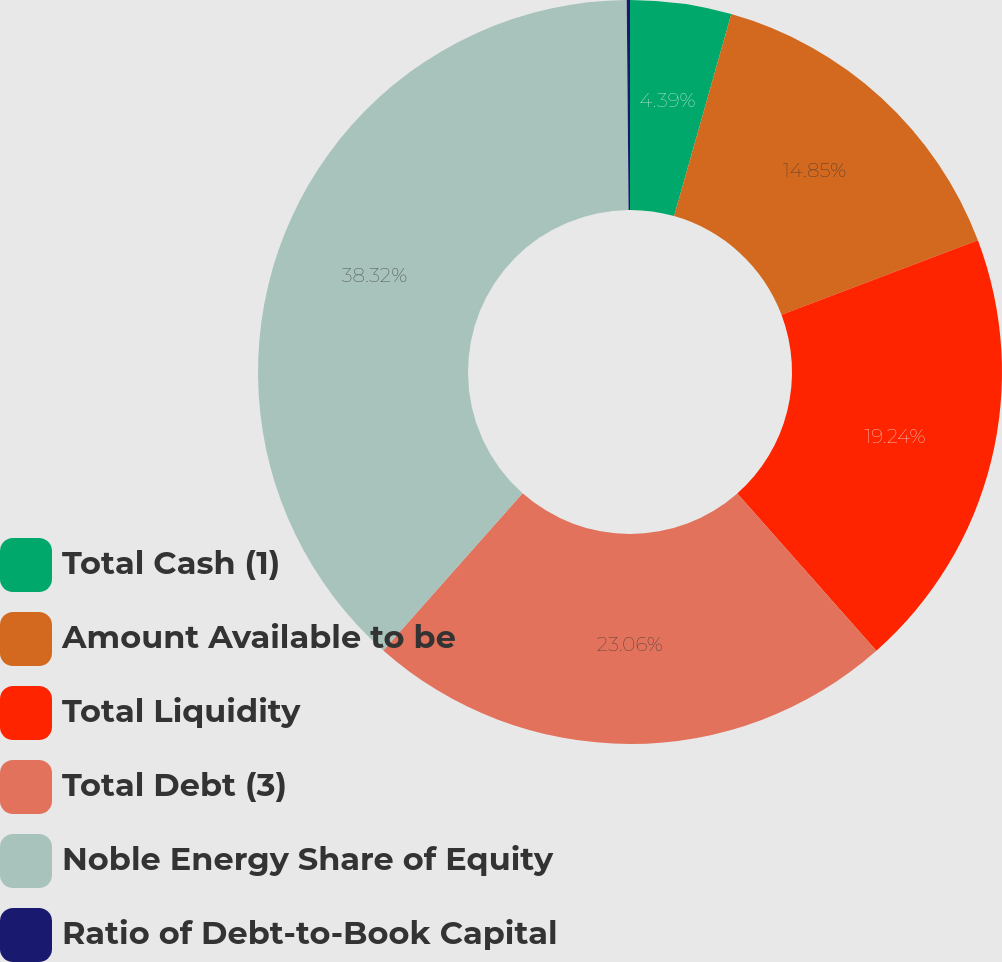<chart> <loc_0><loc_0><loc_500><loc_500><pie_chart><fcel>Total Cash (1)<fcel>Amount Available to be<fcel>Total Liquidity<fcel>Total Debt (3)<fcel>Noble Energy Share of Equity<fcel>Ratio of Debt-to-Book Capital<nl><fcel>4.39%<fcel>14.85%<fcel>19.24%<fcel>23.06%<fcel>38.32%<fcel>0.14%<nl></chart> 